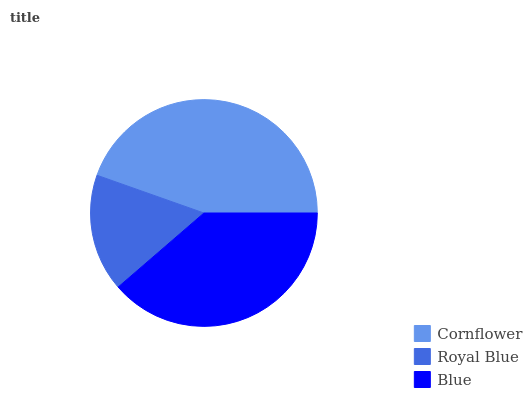Is Royal Blue the minimum?
Answer yes or no. Yes. Is Cornflower the maximum?
Answer yes or no. Yes. Is Blue the minimum?
Answer yes or no. No. Is Blue the maximum?
Answer yes or no. No. Is Blue greater than Royal Blue?
Answer yes or no. Yes. Is Royal Blue less than Blue?
Answer yes or no. Yes. Is Royal Blue greater than Blue?
Answer yes or no. No. Is Blue less than Royal Blue?
Answer yes or no. No. Is Blue the high median?
Answer yes or no. Yes. Is Blue the low median?
Answer yes or no. Yes. Is Royal Blue the high median?
Answer yes or no. No. Is Royal Blue the low median?
Answer yes or no. No. 